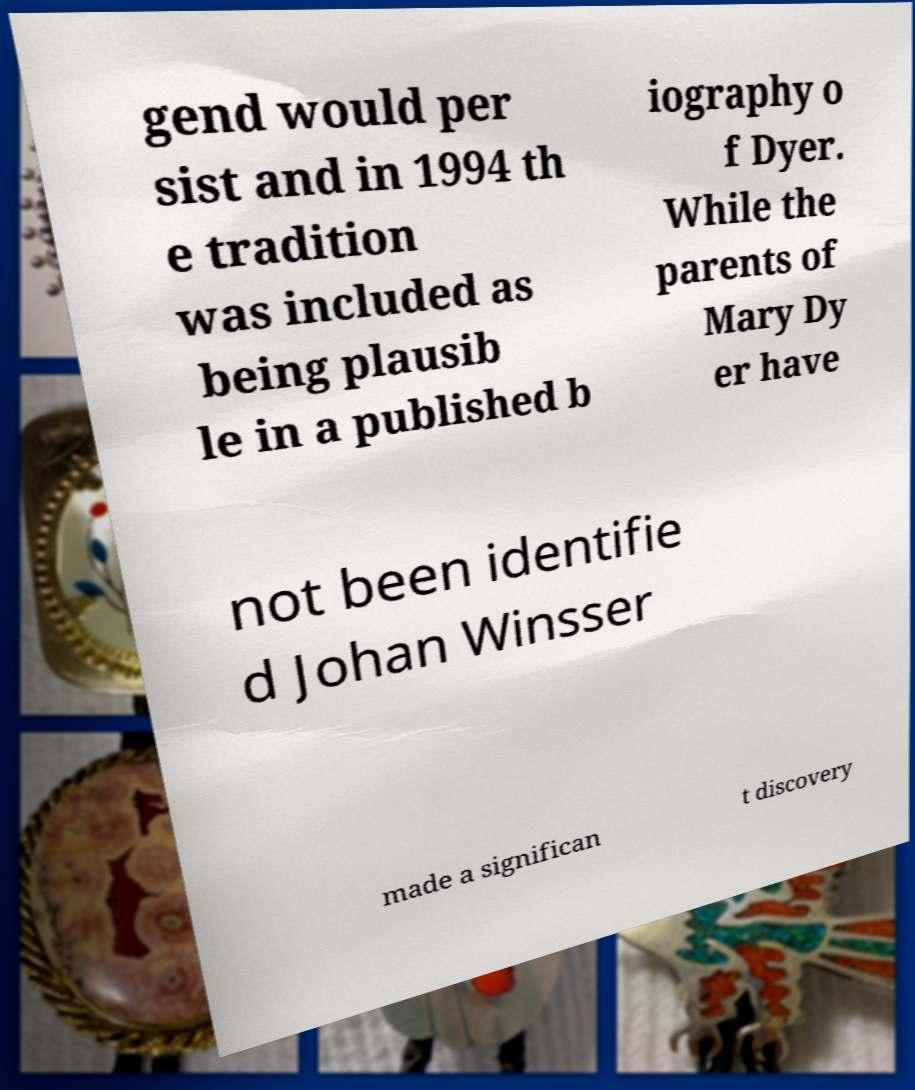Can you read and provide the text displayed in the image?This photo seems to have some interesting text. Can you extract and type it out for me? gend would per sist and in 1994 th e tradition was included as being plausib le in a published b iography o f Dyer. While the parents of Mary Dy er have not been identifie d Johan Winsser made a significan t discovery 